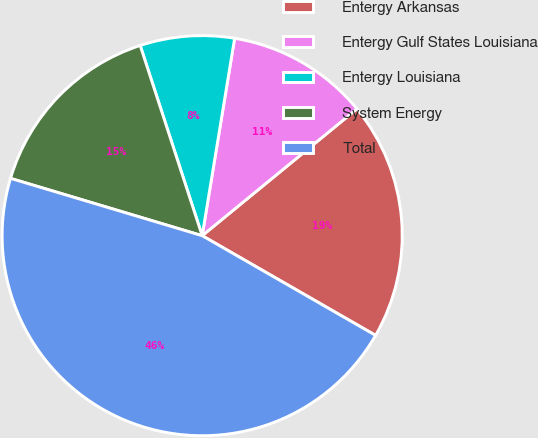<chart> <loc_0><loc_0><loc_500><loc_500><pie_chart><fcel>Entergy Arkansas<fcel>Entergy Gulf States Louisiana<fcel>Entergy Louisiana<fcel>System Energy<fcel>Total<nl><fcel>19.23%<fcel>11.48%<fcel>7.61%<fcel>15.36%<fcel>46.32%<nl></chart> 